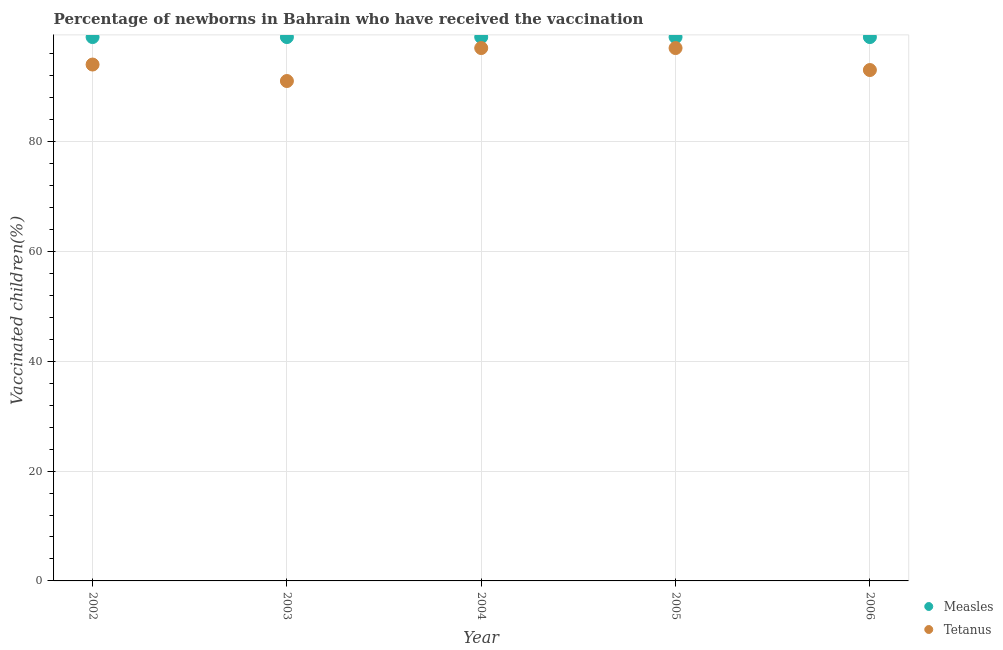How many different coloured dotlines are there?
Offer a terse response. 2. What is the percentage of newborns who received vaccination for tetanus in 2004?
Your answer should be compact. 97. Across all years, what is the maximum percentage of newborns who received vaccination for tetanus?
Give a very brief answer. 97. Across all years, what is the minimum percentage of newborns who received vaccination for tetanus?
Ensure brevity in your answer.  91. What is the total percentage of newborns who received vaccination for measles in the graph?
Your response must be concise. 495. What is the difference between the percentage of newborns who received vaccination for tetanus in 2004 and that in 2005?
Give a very brief answer. 0. What is the difference between the percentage of newborns who received vaccination for measles in 2002 and the percentage of newborns who received vaccination for tetanus in 2004?
Offer a terse response. 2. What is the average percentage of newborns who received vaccination for tetanus per year?
Provide a short and direct response. 94.4. In the year 2003, what is the difference between the percentage of newborns who received vaccination for tetanus and percentage of newborns who received vaccination for measles?
Your answer should be very brief. -8. In how many years, is the percentage of newborns who received vaccination for measles greater than 64 %?
Provide a short and direct response. 5. What is the ratio of the percentage of newborns who received vaccination for tetanus in 2003 to that in 2006?
Offer a terse response. 0.98. In how many years, is the percentage of newborns who received vaccination for tetanus greater than the average percentage of newborns who received vaccination for tetanus taken over all years?
Provide a succinct answer. 2. Is the sum of the percentage of newborns who received vaccination for measles in 2004 and 2005 greater than the maximum percentage of newborns who received vaccination for tetanus across all years?
Give a very brief answer. Yes. Does the percentage of newborns who received vaccination for measles monotonically increase over the years?
Your response must be concise. No. How many dotlines are there?
Ensure brevity in your answer.  2. How many years are there in the graph?
Provide a succinct answer. 5. What is the difference between two consecutive major ticks on the Y-axis?
Ensure brevity in your answer.  20. What is the title of the graph?
Your answer should be very brief. Percentage of newborns in Bahrain who have received the vaccination. What is the label or title of the Y-axis?
Your answer should be very brief. Vaccinated children(%)
. What is the Vaccinated children(%)
 of Tetanus in 2002?
Your answer should be compact. 94. What is the Vaccinated children(%)
 of Measles in 2003?
Make the answer very short. 99. What is the Vaccinated children(%)
 of Tetanus in 2003?
Offer a very short reply. 91. What is the Vaccinated children(%)
 in Tetanus in 2004?
Your response must be concise. 97. What is the Vaccinated children(%)
 in Tetanus in 2005?
Give a very brief answer. 97. What is the Vaccinated children(%)
 in Tetanus in 2006?
Give a very brief answer. 93. Across all years, what is the maximum Vaccinated children(%)
 in Tetanus?
Ensure brevity in your answer.  97. Across all years, what is the minimum Vaccinated children(%)
 of Tetanus?
Your response must be concise. 91. What is the total Vaccinated children(%)
 of Measles in the graph?
Offer a very short reply. 495. What is the total Vaccinated children(%)
 in Tetanus in the graph?
Provide a short and direct response. 472. What is the difference between the Vaccinated children(%)
 of Tetanus in 2002 and that in 2003?
Your answer should be very brief. 3. What is the difference between the Vaccinated children(%)
 in Tetanus in 2002 and that in 2006?
Keep it short and to the point. 1. What is the difference between the Vaccinated children(%)
 of Measles in 2003 and that in 2004?
Your answer should be very brief. 0. What is the difference between the Vaccinated children(%)
 of Tetanus in 2003 and that in 2004?
Provide a short and direct response. -6. What is the difference between the Vaccinated children(%)
 in Measles in 2003 and that in 2005?
Your answer should be compact. 0. What is the difference between the Vaccinated children(%)
 in Measles in 2003 and that in 2006?
Your response must be concise. 0. What is the difference between the Vaccinated children(%)
 in Tetanus in 2004 and that in 2005?
Your answer should be very brief. 0. What is the difference between the Vaccinated children(%)
 in Measles in 2004 and that in 2006?
Your answer should be very brief. 0. What is the difference between the Vaccinated children(%)
 of Tetanus in 2004 and that in 2006?
Provide a succinct answer. 4. What is the difference between the Vaccinated children(%)
 in Measles in 2005 and that in 2006?
Offer a very short reply. 0. What is the difference between the Vaccinated children(%)
 in Tetanus in 2005 and that in 2006?
Offer a terse response. 4. What is the difference between the Vaccinated children(%)
 in Measles in 2002 and the Vaccinated children(%)
 in Tetanus in 2004?
Ensure brevity in your answer.  2. What is the difference between the Vaccinated children(%)
 of Measles in 2002 and the Vaccinated children(%)
 of Tetanus in 2005?
Make the answer very short. 2. What is the difference between the Vaccinated children(%)
 of Measles in 2002 and the Vaccinated children(%)
 of Tetanus in 2006?
Your answer should be very brief. 6. What is the difference between the Vaccinated children(%)
 of Measles in 2003 and the Vaccinated children(%)
 of Tetanus in 2004?
Give a very brief answer. 2. What is the difference between the Vaccinated children(%)
 in Measles in 2004 and the Vaccinated children(%)
 in Tetanus in 2006?
Make the answer very short. 6. What is the difference between the Vaccinated children(%)
 in Measles in 2005 and the Vaccinated children(%)
 in Tetanus in 2006?
Your answer should be very brief. 6. What is the average Vaccinated children(%)
 of Tetanus per year?
Your answer should be compact. 94.4. In the year 2004, what is the difference between the Vaccinated children(%)
 in Measles and Vaccinated children(%)
 in Tetanus?
Ensure brevity in your answer.  2. What is the ratio of the Vaccinated children(%)
 in Measles in 2002 to that in 2003?
Your response must be concise. 1. What is the ratio of the Vaccinated children(%)
 in Tetanus in 2002 to that in 2003?
Offer a very short reply. 1.03. What is the ratio of the Vaccinated children(%)
 in Measles in 2002 to that in 2004?
Your response must be concise. 1. What is the ratio of the Vaccinated children(%)
 of Tetanus in 2002 to that in 2004?
Your answer should be very brief. 0.97. What is the ratio of the Vaccinated children(%)
 in Tetanus in 2002 to that in 2005?
Provide a short and direct response. 0.97. What is the ratio of the Vaccinated children(%)
 in Measles in 2002 to that in 2006?
Offer a terse response. 1. What is the ratio of the Vaccinated children(%)
 in Tetanus in 2002 to that in 2006?
Offer a terse response. 1.01. What is the ratio of the Vaccinated children(%)
 of Tetanus in 2003 to that in 2004?
Ensure brevity in your answer.  0.94. What is the ratio of the Vaccinated children(%)
 of Tetanus in 2003 to that in 2005?
Offer a terse response. 0.94. What is the ratio of the Vaccinated children(%)
 in Tetanus in 2003 to that in 2006?
Keep it short and to the point. 0.98. What is the ratio of the Vaccinated children(%)
 of Tetanus in 2004 to that in 2005?
Offer a very short reply. 1. What is the ratio of the Vaccinated children(%)
 in Tetanus in 2004 to that in 2006?
Provide a succinct answer. 1.04. What is the ratio of the Vaccinated children(%)
 of Measles in 2005 to that in 2006?
Give a very brief answer. 1. What is the ratio of the Vaccinated children(%)
 of Tetanus in 2005 to that in 2006?
Ensure brevity in your answer.  1.04. 